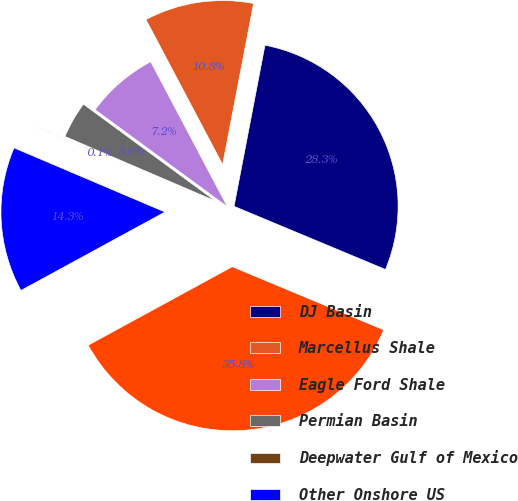Convert chart to OTSL. <chart><loc_0><loc_0><loc_500><loc_500><pie_chart><fcel>DJ Basin<fcel>Marcellus Shale<fcel>Eagle Ford Shale<fcel>Permian Basin<fcel>Deepwater Gulf of Mexico<fcel>Other Onshore US<fcel>Total<nl><fcel>28.27%<fcel>10.76%<fcel>7.19%<fcel>3.62%<fcel>0.05%<fcel>14.34%<fcel>35.77%<nl></chart> 